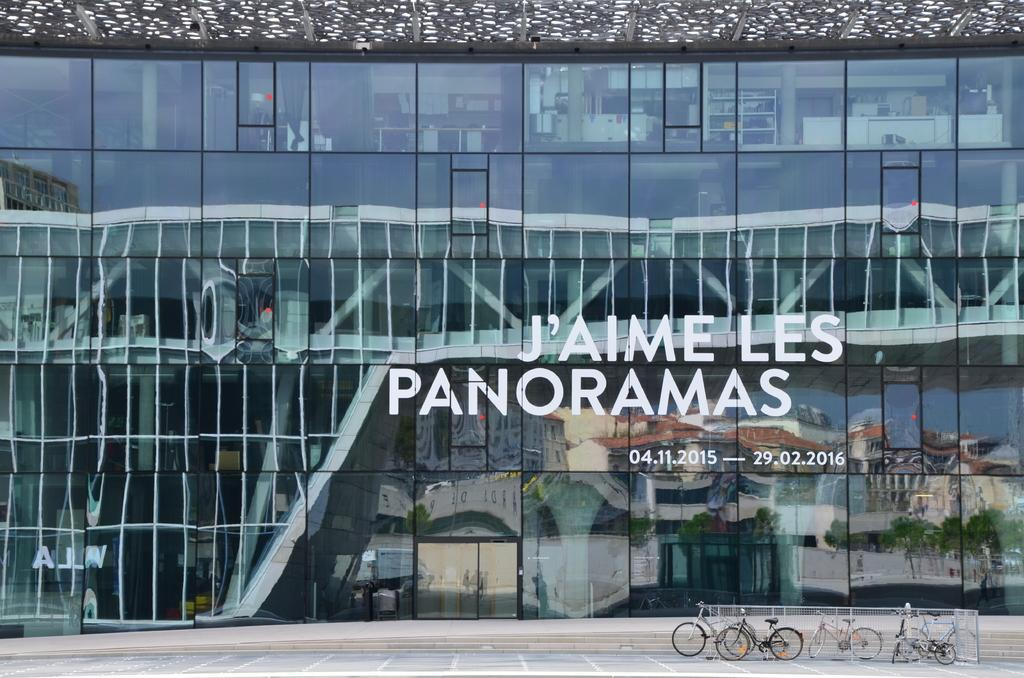What type of building is visible in the image? There is a glass building in the image. What can be seen on the ground near the building? There are bicycles on the ground in the image. How many legs does the water have in the image? There is no water present in the image, so it is not possible to determine how many legs it might have. 